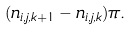<formula> <loc_0><loc_0><loc_500><loc_500>( n _ { i , j , k + 1 } - n _ { i , j , k } ) \pi .</formula> 